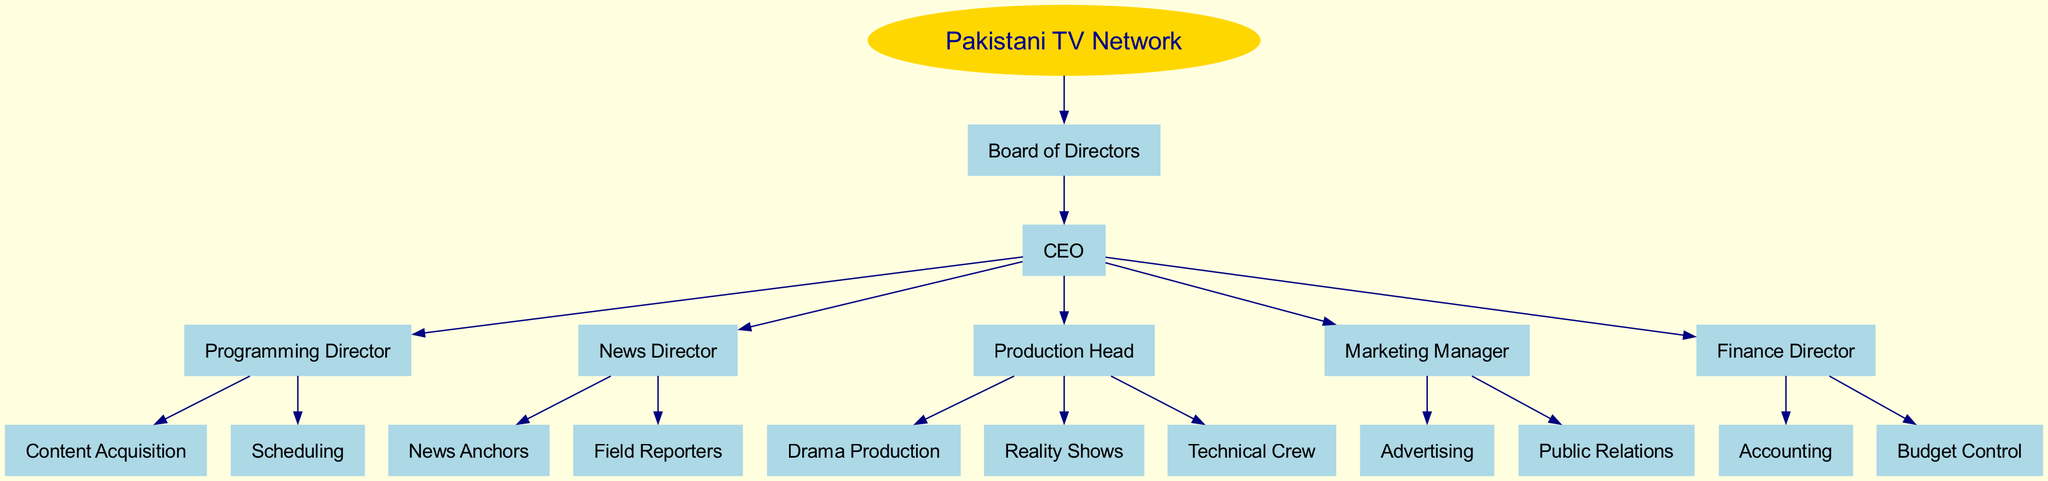What's at the top of the organizational structure? The top of the organizational structure is the "Pakistani TV Network." This is the root node of the diagram, representing the entire network.
Answer: Pakistani TV Network How many main departments report directly to the CEO? There are five main departments listed under the CEO's purview: Programming, News, Production, Marketing, and Finance. Each of these is represented as a child node under the CEO.
Answer: Five Which department is responsible for news coverage? The "News Director" department is specifically responsible for news coverage, overseeing roles such as News Anchors and Field Reporters.
Answer: News Director How many roles are under the Production Head? The Production Head oversees three roles: Drama Production, Reality Shows, and Technical Crew, which are listed as children under that department.
Answer: Three What are two roles under the Marketing Manager? The Marketing Manager oversees two roles: Advertising and Public Relations, both of which are represented as child nodes under that department.
Answer: Advertising and Public Relations What is the relationship between the CEO and the Programming Director? The Programming Director reports directly to the CEO; this hierarchical relationship can be identified by following the edge connecting these two nodes in the diagram.
Answer: Reports directly Which department handles budget control? The Finance Director's department is responsible for budget control, according to the organizational structure, as denoted in its child nodes.
Answer: Finance Director Are there any roles listed under Content Acquisition? There are no specific roles listed under Content Acquisition; it appears as a single node without children in the diagram.
Answer: No What is the main function of the Board of Directors? The Board of Directors serves as the governing body of the network, overseeing the overall operations and strategic direction of the TV Network.
Answer: Governing body 